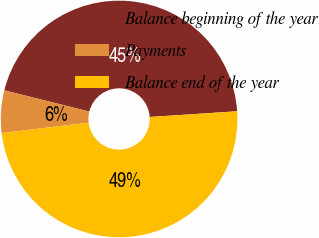Convert chart. <chart><loc_0><loc_0><loc_500><loc_500><pie_chart><fcel>Balance beginning of the year<fcel>Payments<fcel>Balance end of the year<nl><fcel>45.07%<fcel>5.8%<fcel>49.13%<nl></chart> 